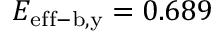<formula> <loc_0><loc_0><loc_500><loc_500>E _ { e f f - b , y } = 0 . 6 8 9</formula> 